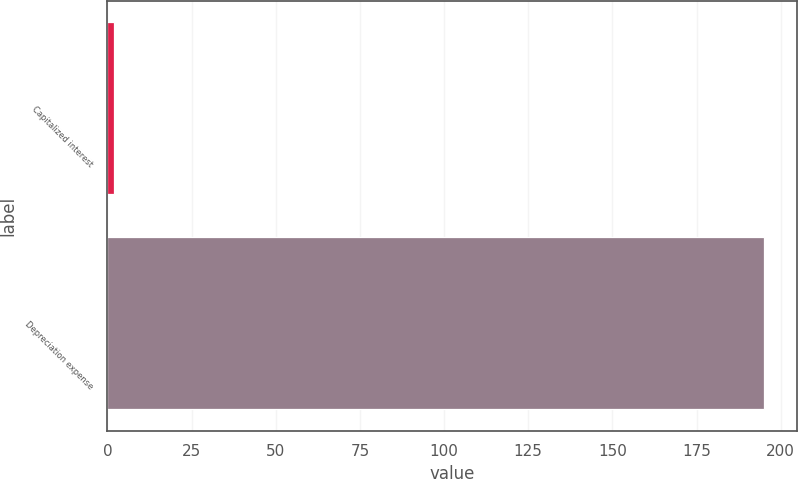<chart> <loc_0><loc_0><loc_500><loc_500><bar_chart><fcel>Capitalized interest<fcel>Depreciation expense<nl><fcel>2<fcel>195<nl></chart> 